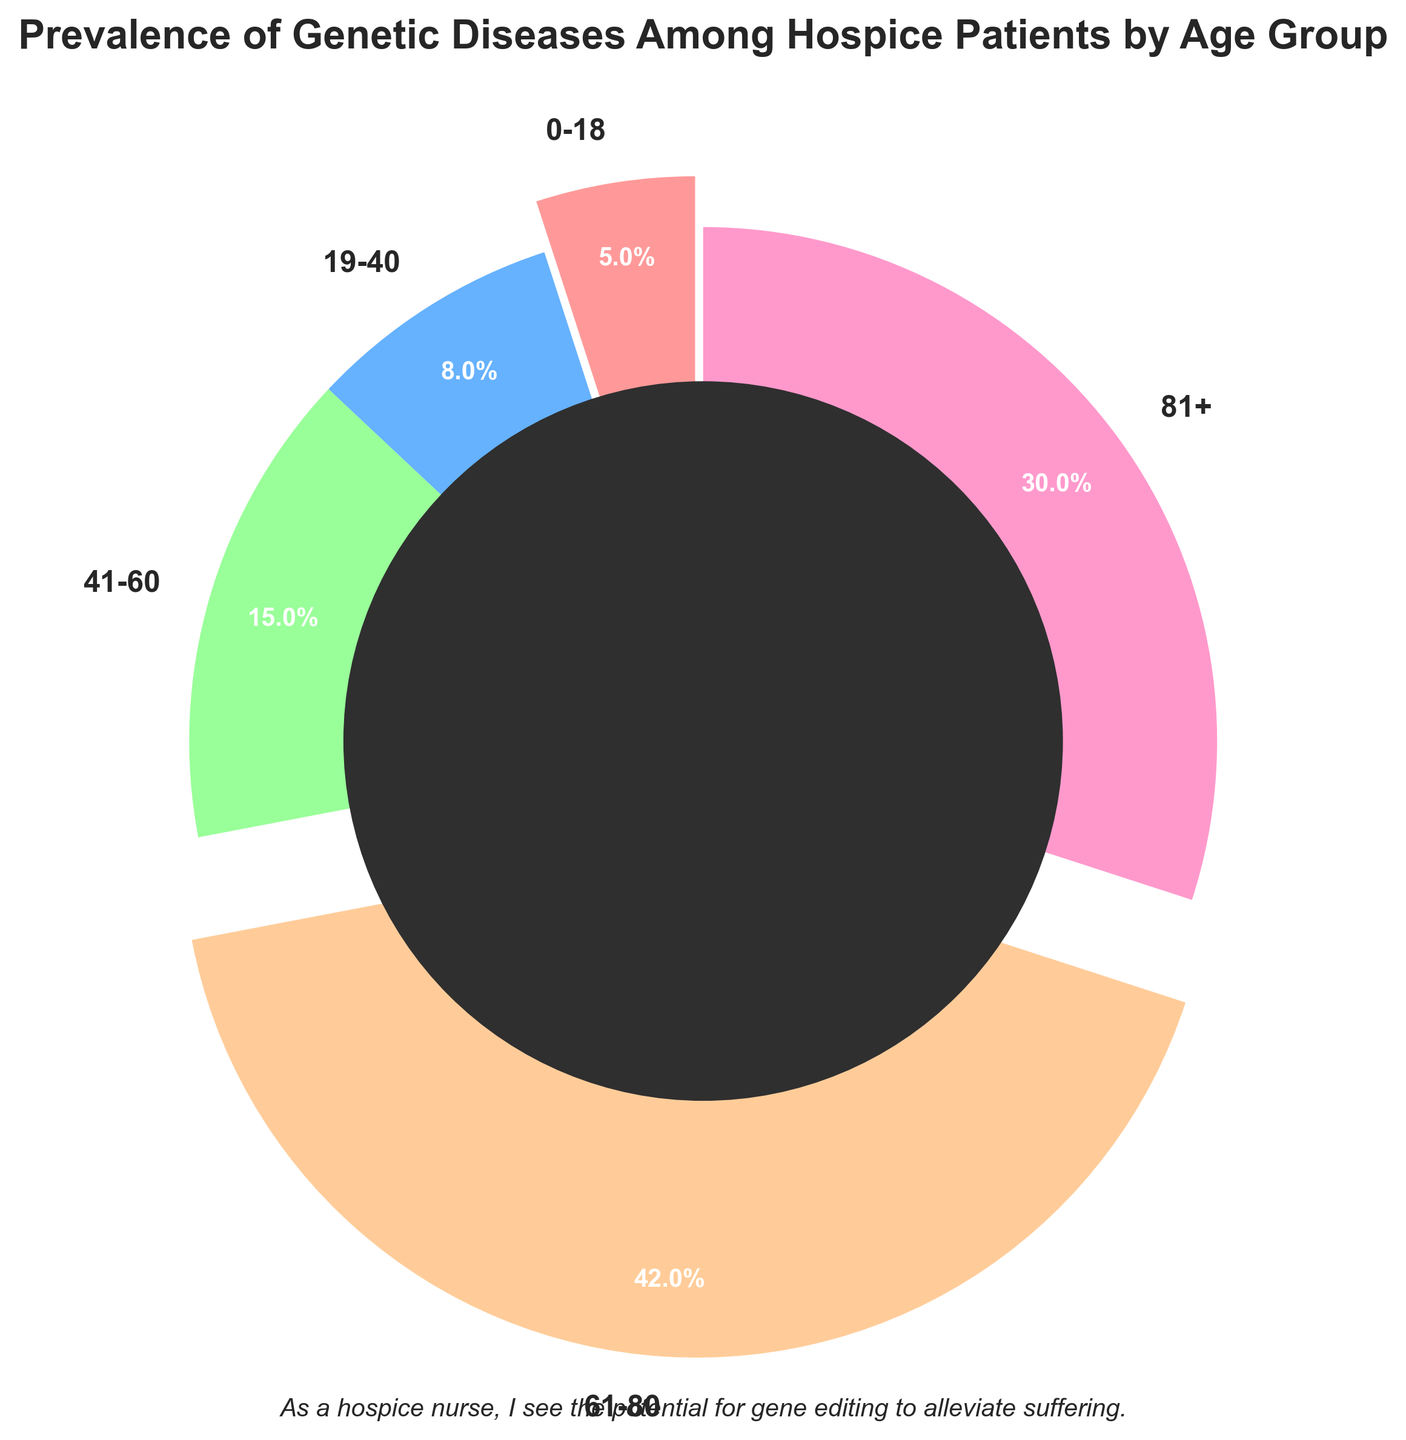What percentage of hospice patients with genetic diseases falls in the 61-80 age group? Look at the pie chart and locate the segment labeled "61-80". The percentage is annotated inside the segment as 42%.
Answer: 42% Which age group has the highest prevalence of genetic diseases among hospice patients? Identify the largest segment in the pie chart. The 61-80 age group occupies the largest portion of the chart, with a percentage of 42%.
Answer: 61-80 What is the total percentage of hospice patients with genetic diseases aged 41 and above? Add the percentages of the age groups 41-60, 61-80, and 81+. This is calculated as 15% + 42% + 30% = 87%.
Answer: 87% How does the prevalence of genetic diseases among patients aged 81+ compare to those aged 0-18? Compare the segments' sizes for the age groups 81+ and 0-18. The 81+ segment represents 30%, whereas the 0-18 segment represents only 5%. Thus, the prevalence is significantly higher in the 81+ age group.
Answer: Significantly higher Is the prevalence of genetic diseases higher in patients aged 0-18 or 19-40? Compare the percentages listed in the segments for 0-18 and 19-40. The 19-40 age group has a percentage of 8%, while the 0-18 age group has 5%.
Answer: 19-40 What color represents the age group 41-60, and what is its percentage? Identify the color coded for the 41-60 segment and read the percentage value within the same segment. The color is green, and it represents 15%.
Answer: Green, 15% What is the difference in the percentage of patients aged 61-80 compared to those aged 41-60? Subtract the percentage of the 41-60 age group from the percentage of the 61-80 age group: 42% - 15% = 27%.
Answer: 27% If you combine the prevalence percentages of the 19-40 and 0-18 age groups, what is the result? Sum the percentages of the 19-40 and 0-18 segments: 8% + 5% = 13%.
Answer: 13% Which age groups are represented by the second largest and smallest segments, respectively? Identify the second largest and smallest segments by examining the chart. The second largest is 81+ at 30%, and the smallest is 0-18 at 5%.
Answer: 81+, 0-18 